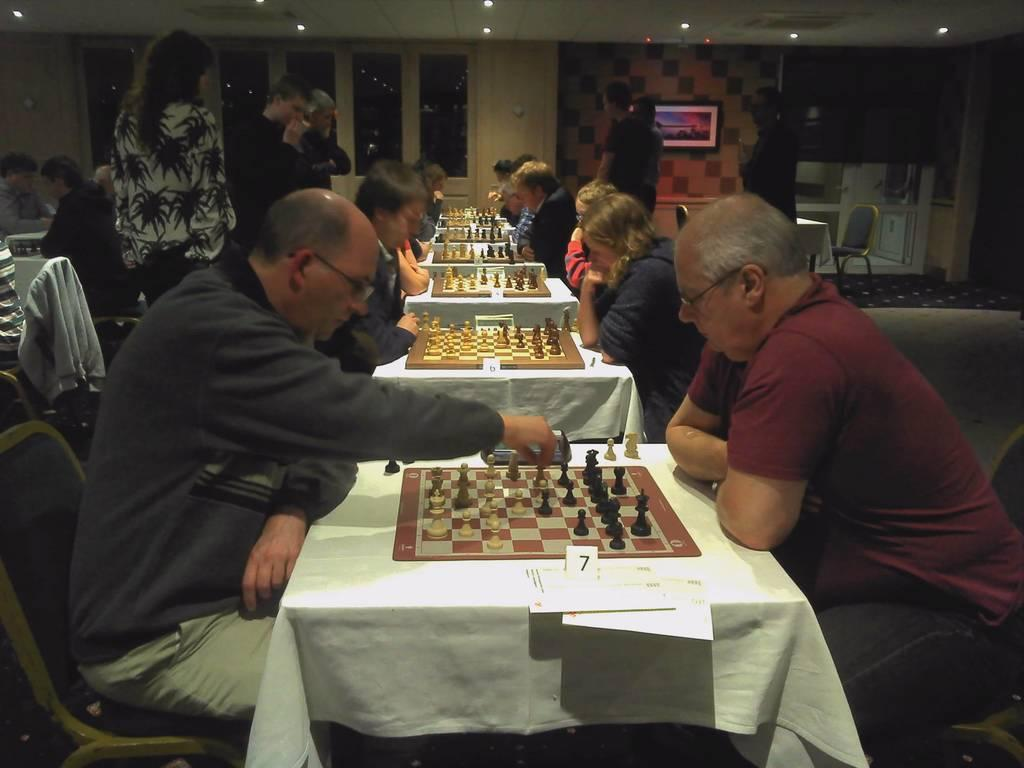What type of tables are in the image? There are serial tables in the image. What are the people in front of the tables doing? The people are sitting in front of the tables and playing chess. Are there any other people visible in the image? Yes, there are people standing at the back. Can you see any zoo animals playing on a swing in the image? No, there are no zoo animals or swings present in the image. 